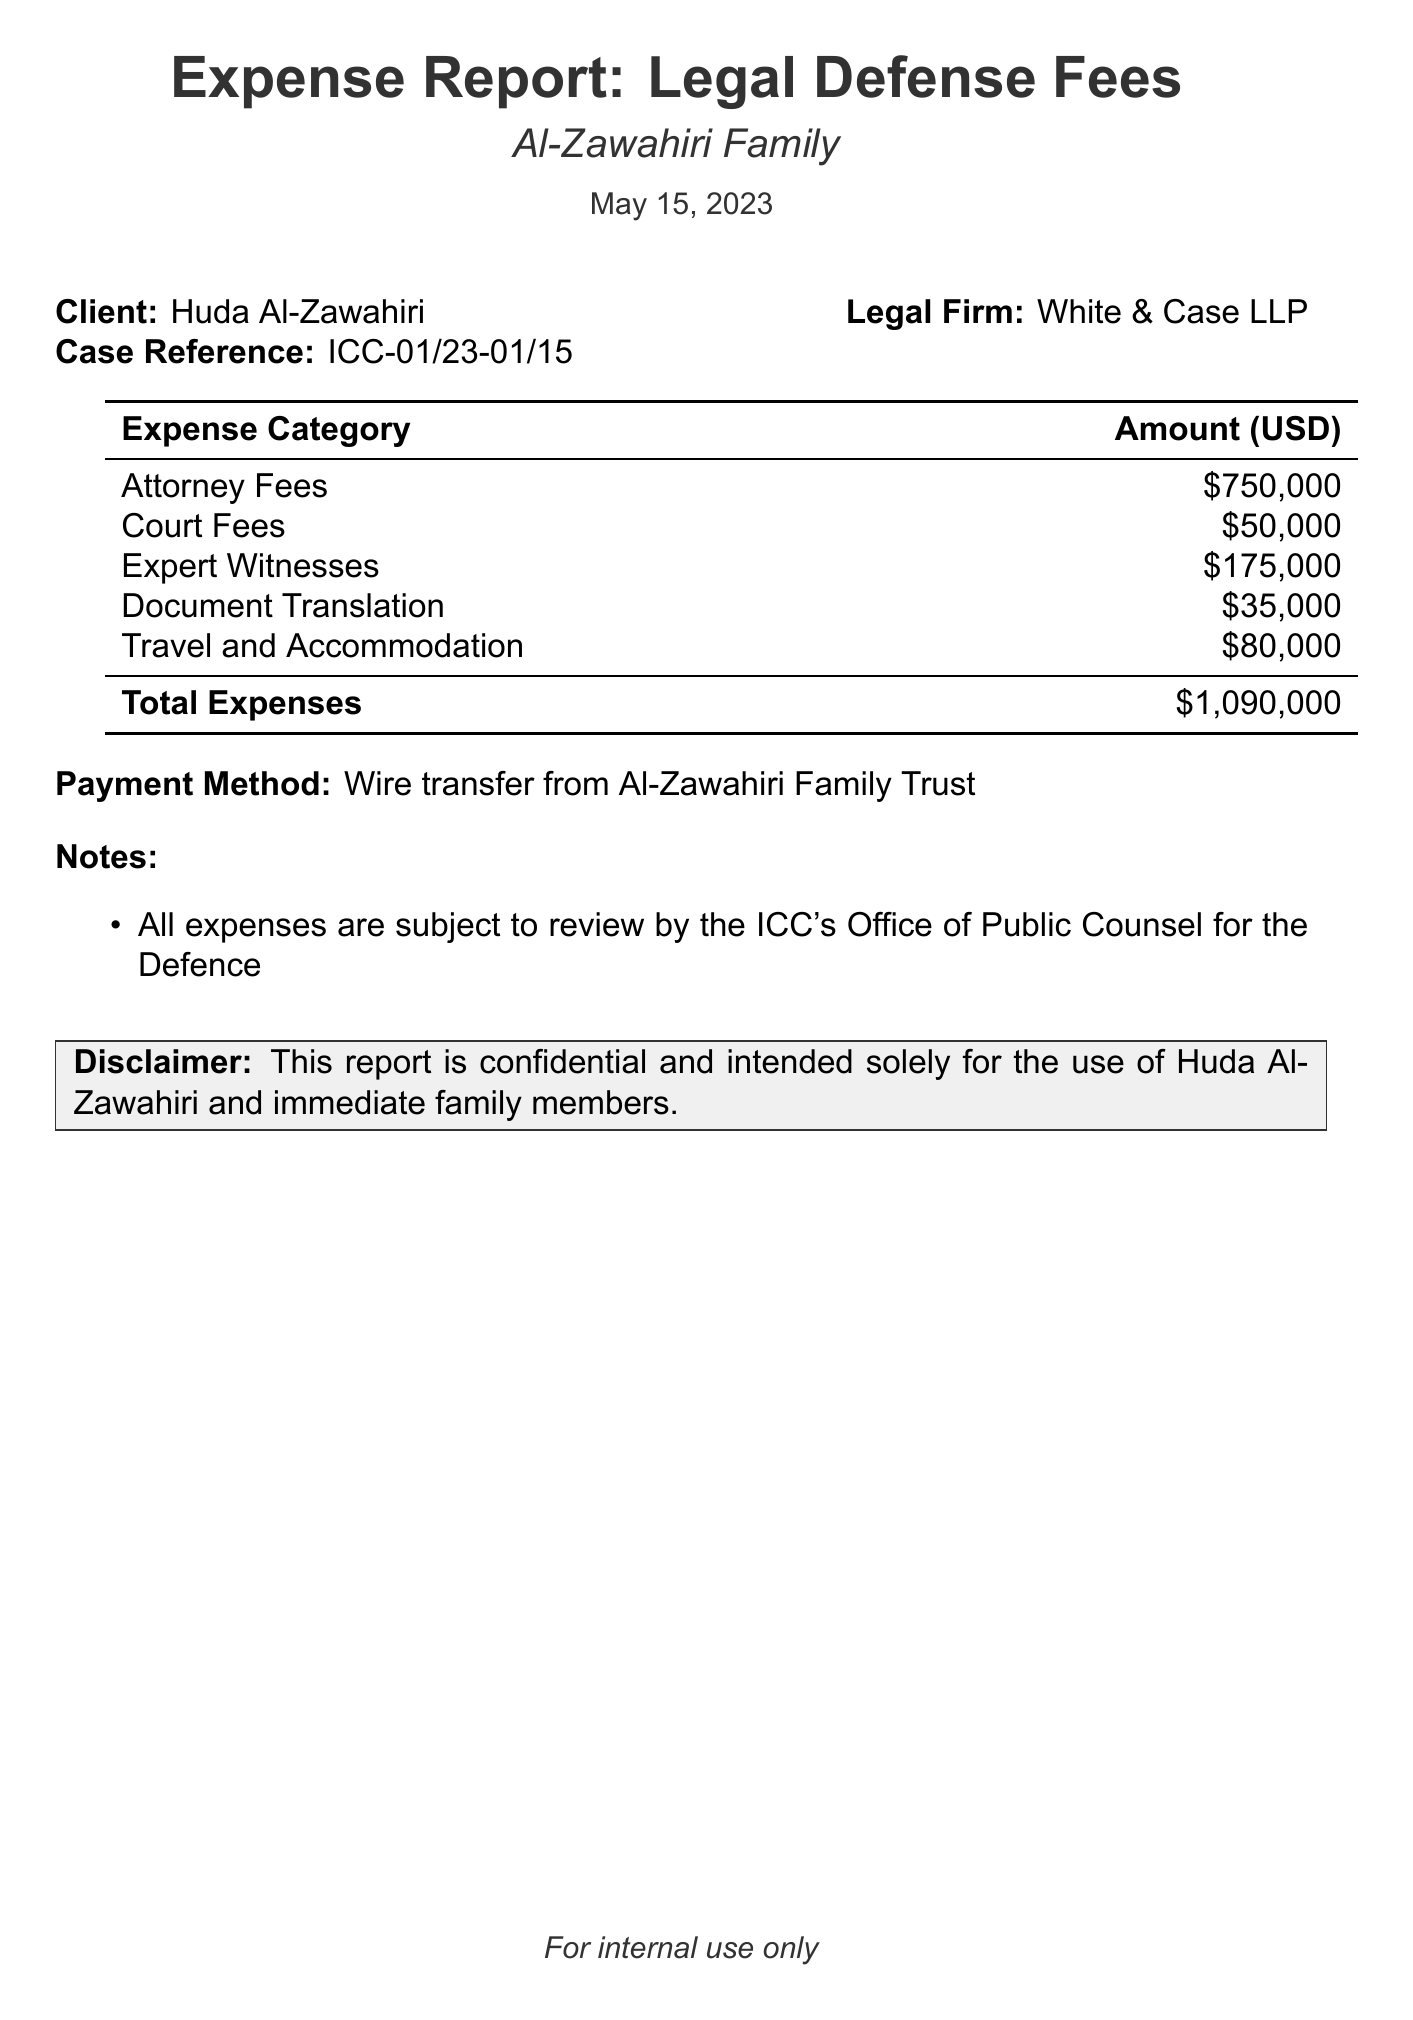What is the total amount of expenses? The total amount of expenses is indicated in the summary at the end of the document, which combines all categories of expenses.
Answer: $1,090,000 Who is the client mentioned in the report? The report specifies the name of the client at the beginning.
Answer: Huda Al-Zawahiri What date was the report issued? The issuance date of the report is stated in the document, which is shown prominently.
Answer: May 15, 2023 What is the name of the legal firm involved? The legal firm's name is clearly listed in the details.
Answer: White & Case LLP How much was spent on attorney fees? The specific amount spent on attorney fees can be found under the expense categories.
Answer: $750,000 What category incurred the highest expense? To find the category with the highest expense, one needs to compare all listed categories in the expense table.
Answer: Attorney Fees What payment method was used for the expenses? The payment method is mentioned towards the end of the report for clarity.
Answer: Wire transfer from Al-Zawahiri Family Trust What note mentions the review process? A note regarding the review process by the ICC is included in the notes section of the report.
Answer: All expenses are subject to review by the ICC's Office of Public Counsel for the Defence How much was allocated for travel and accommodation? The amount allocated for travel and accommodation is specified in the expense categories section.
Answer: $80,000 What type of document is this? This document details specific expenses related to a legal case, indicating its nature as a financial report for legal fees.
Answer: Expense Report 